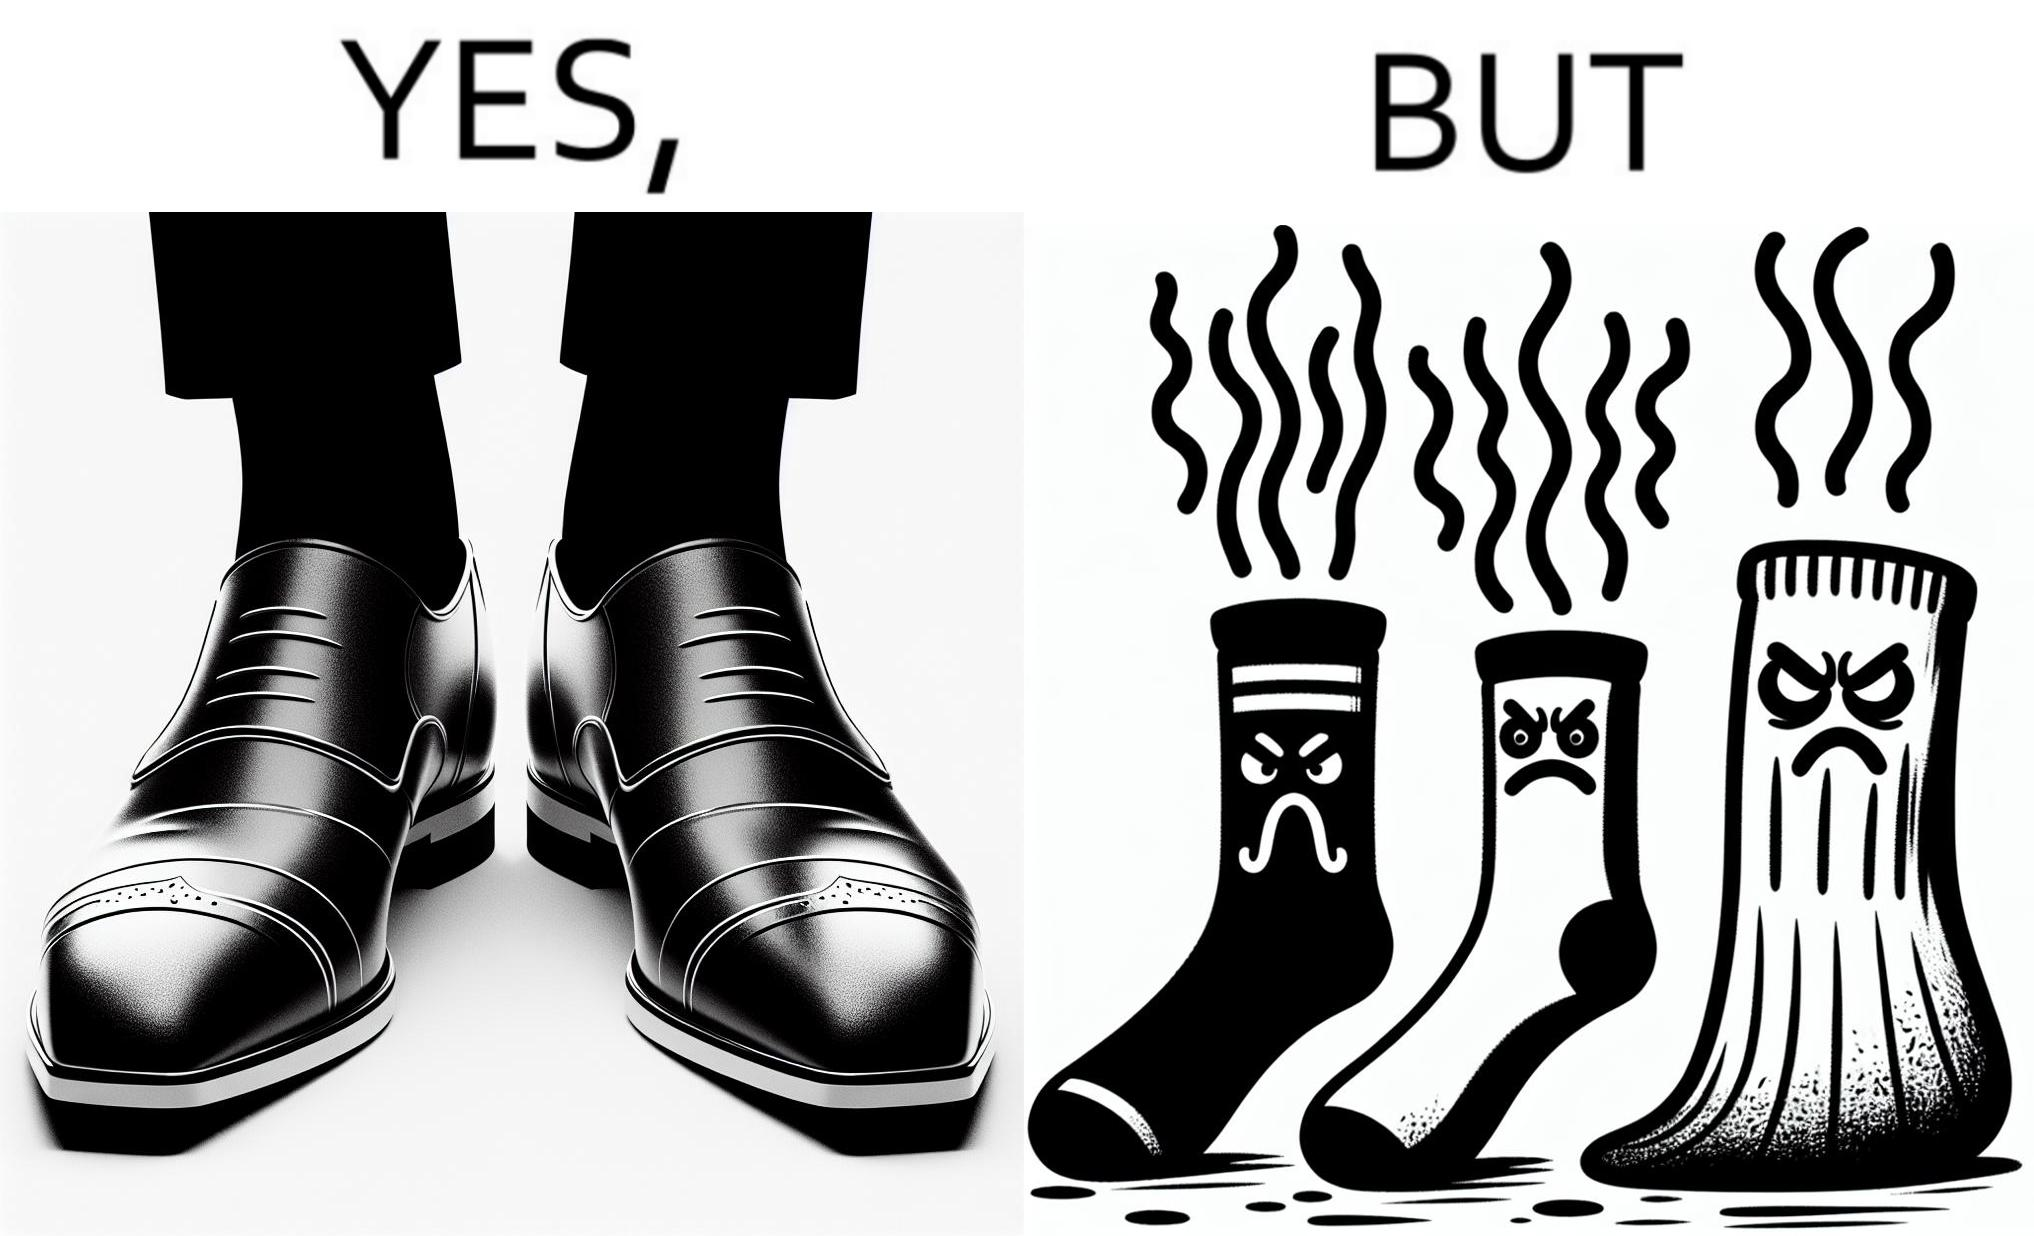Is this a satirical image? Yes, this image is satirical. 